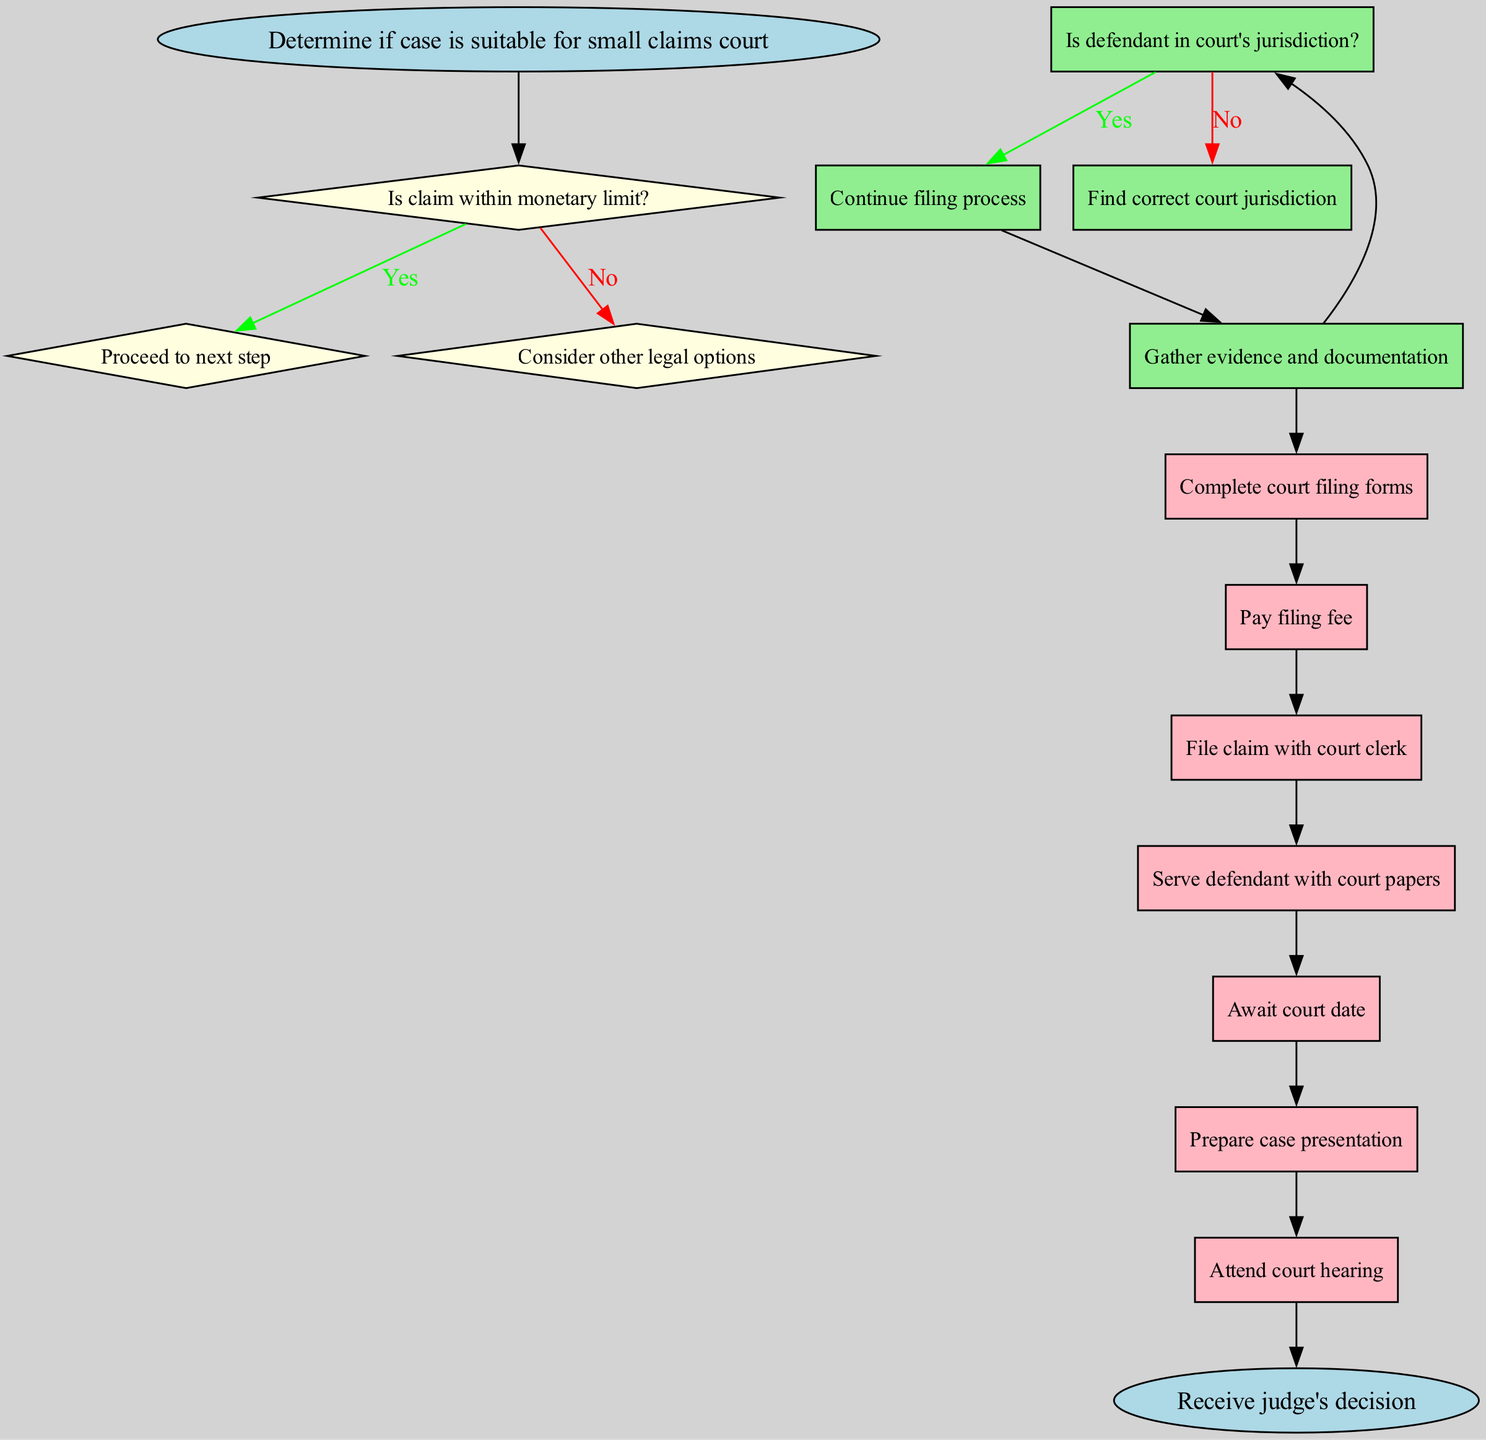What is the starting point of the flowchart? The starting point of the flowchart is where the process begins, indicated by the 'start' node, which states "Determine if case is suitable for small claims court."
Answer: Determine if case is suitable for small claims court How many decision points are there in the flowchart? The flowchart contains two decision nodes, indicated by the conditions that must be checked before proceeding to the steps of the claim process.
Answer: 2 What is the first step after the last 'yes' decision? The first step after the last 'yes' decision is the initial action taken in the process, which is "Gather evidence and documentation."
Answer: Gather evidence and documentation What happens if the claim is not within the monetary limit? If the claim is not within the monetary limit, you are directed to consider other legal options, as indicated in the flowchart.
Answer: Consider other legal options What is the final outcome indicated in the flowchart? The final outcome indicated in the flowchart is represented by the end node stating "Receive judge's decision."
Answer: Receive judge's decision What must be done if the defendant is not in the court's jurisdiction? If the defendant is not in the court's jurisdiction, the flowchart suggests finding the correct court jurisdiction before proceeding.
Answer: Find correct court jurisdiction What step follows the payment of the filing fee? The step that follows the payment of the filing fee is "File claim with court clerk," according to the sequential order presented in the flowchart.
Answer: File claim with court clerk If the defendant is served, what will the party await next? After the defendant is served, the next action indicates that the party will await the court date, as outlined in the following steps of the flowchart.
Answer: Await court date Why is it necessary to gather evidence and documentation? Gathering evidence and documentation is necessary as it provides support for your claim, which will be presented in court as part of the case preparation process.
Answer: Supports your claim 